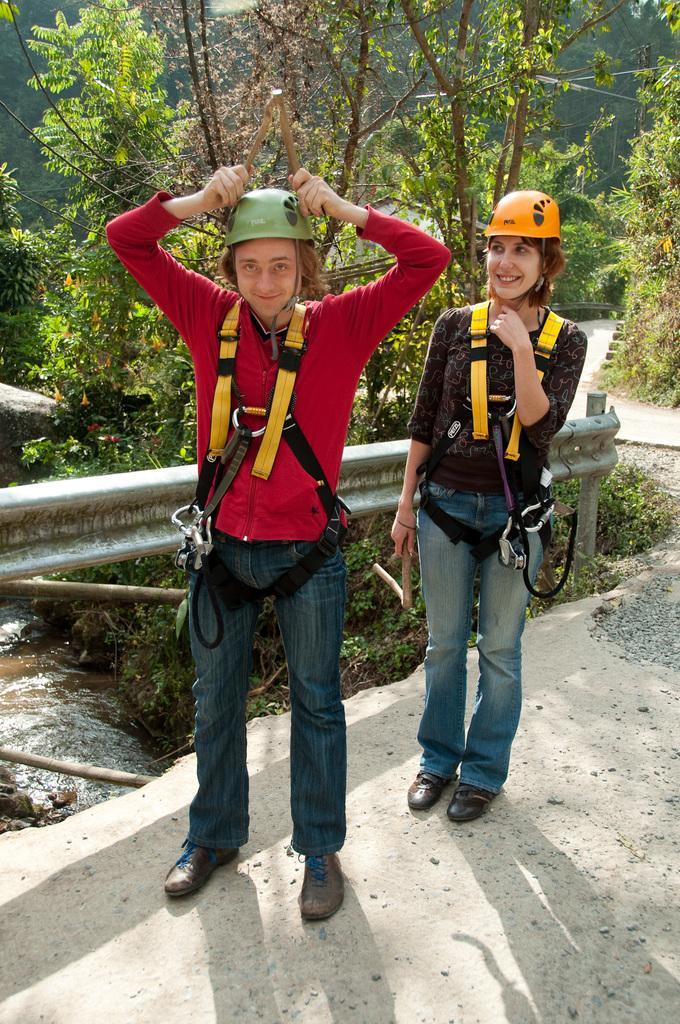Describe this image in one or two sentences. In this picture we can see two persons wore helmets and standing on the ground and smiling and in the background we can see water, trees. 